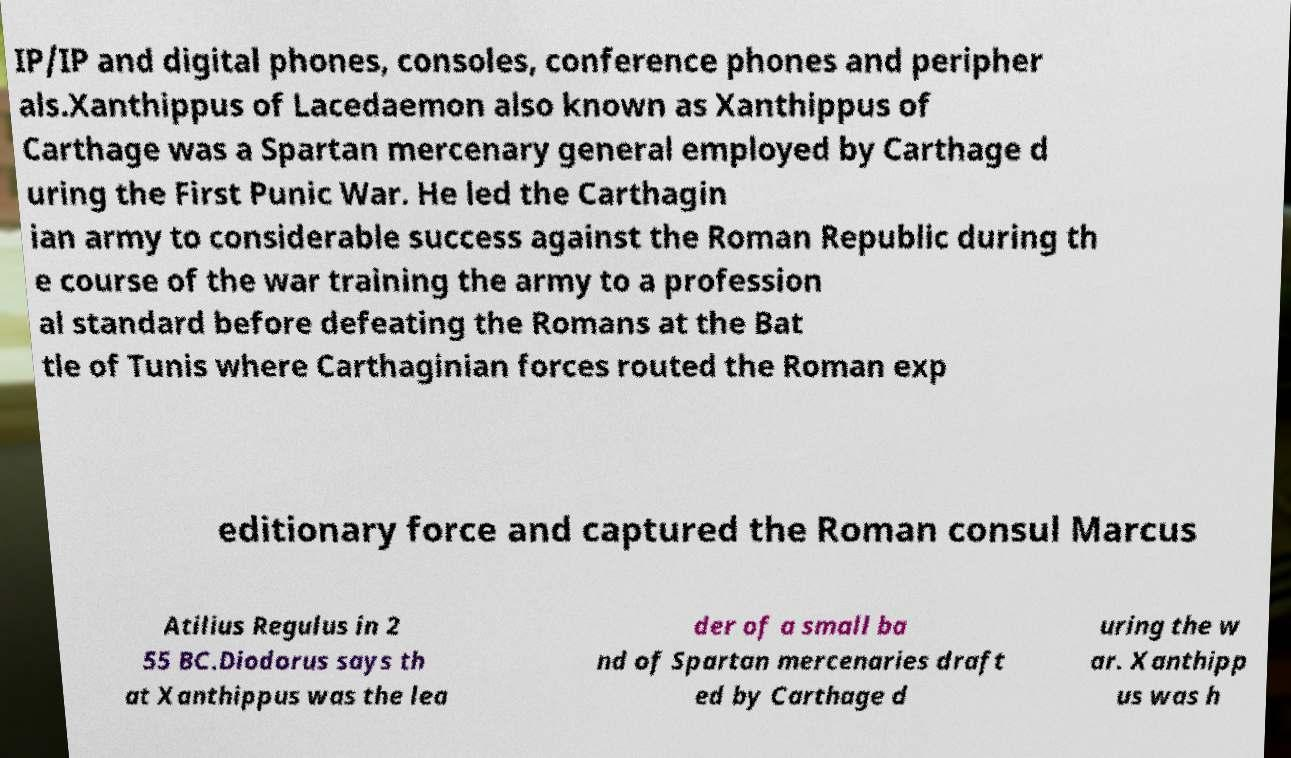For documentation purposes, I need the text within this image transcribed. Could you provide that? IP/IP and digital phones, consoles, conference phones and peripher als.Xanthippus of Lacedaemon also known as Xanthippus of Carthage was a Spartan mercenary general employed by Carthage d uring the First Punic War. He led the Carthagin ian army to considerable success against the Roman Republic during th e course of the war training the army to a profession al standard before defeating the Romans at the Bat tle of Tunis where Carthaginian forces routed the Roman exp editionary force and captured the Roman consul Marcus Atilius Regulus in 2 55 BC.Diodorus says th at Xanthippus was the lea der of a small ba nd of Spartan mercenaries draft ed by Carthage d uring the w ar. Xanthipp us was h 